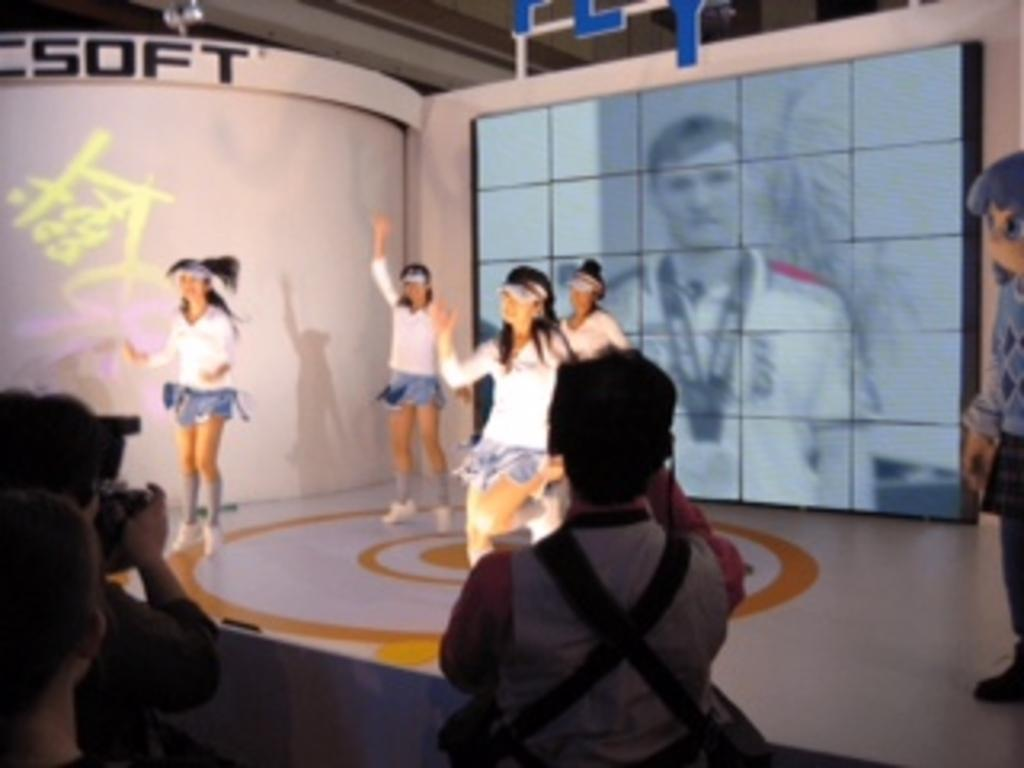What is happening in the image involving the people? Some people are dancing on the floor. What can be seen in the background of the image? There is a screen in the background of the image. Where is the person holding a camera located in the image? The person holding a camera is on the left side of the image. What type of bells can be heard ringing in the image? There are no bells present in the image, and therefore no sound can be heard. Is there a door visible in the image? There is no door visible in the image. --- 